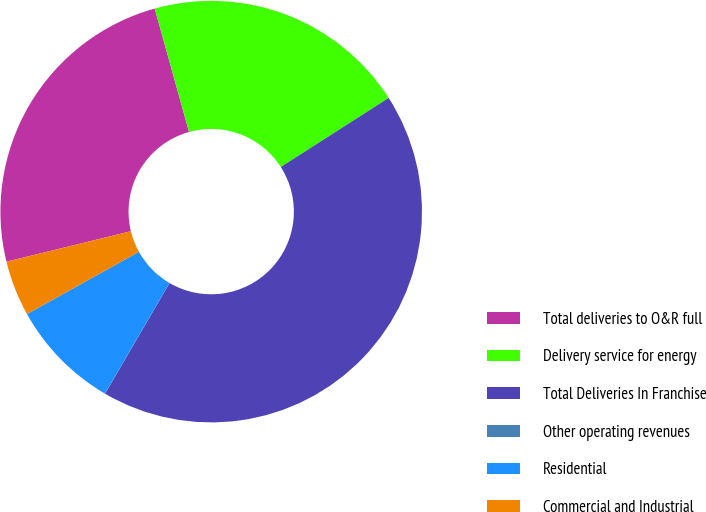Convert chart to OTSL. <chart><loc_0><loc_0><loc_500><loc_500><pie_chart><fcel>Total deliveries to O&R full<fcel>Delivery service for energy<fcel>Total Deliveries In Franchise<fcel>Other operating revenues<fcel>Residential<fcel>Commercial and Industrial<nl><fcel>24.5%<fcel>20.25%<fcel>42.47%<fcel>0.01%<fcel>8.51%<fcel>4.26%<nl></chart> 